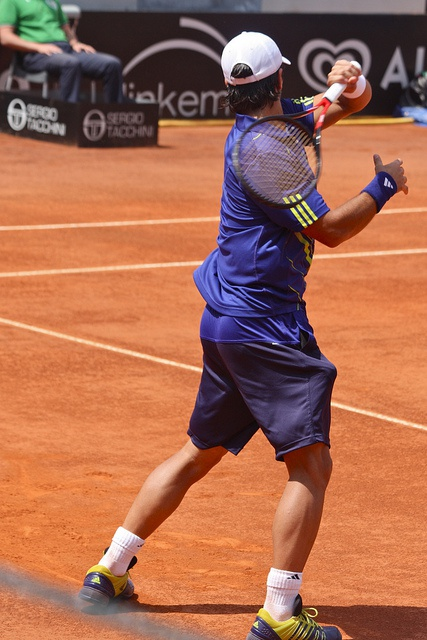Describe the objects in this image and their specific colors. I can see people in turquoise, black, maroon, navy, and blue tones, tennis racket in turquoise, gray, and black tones, chair in turquoise, black, and gray tones, and chair in turquoise, gray, and black tones in this image. 